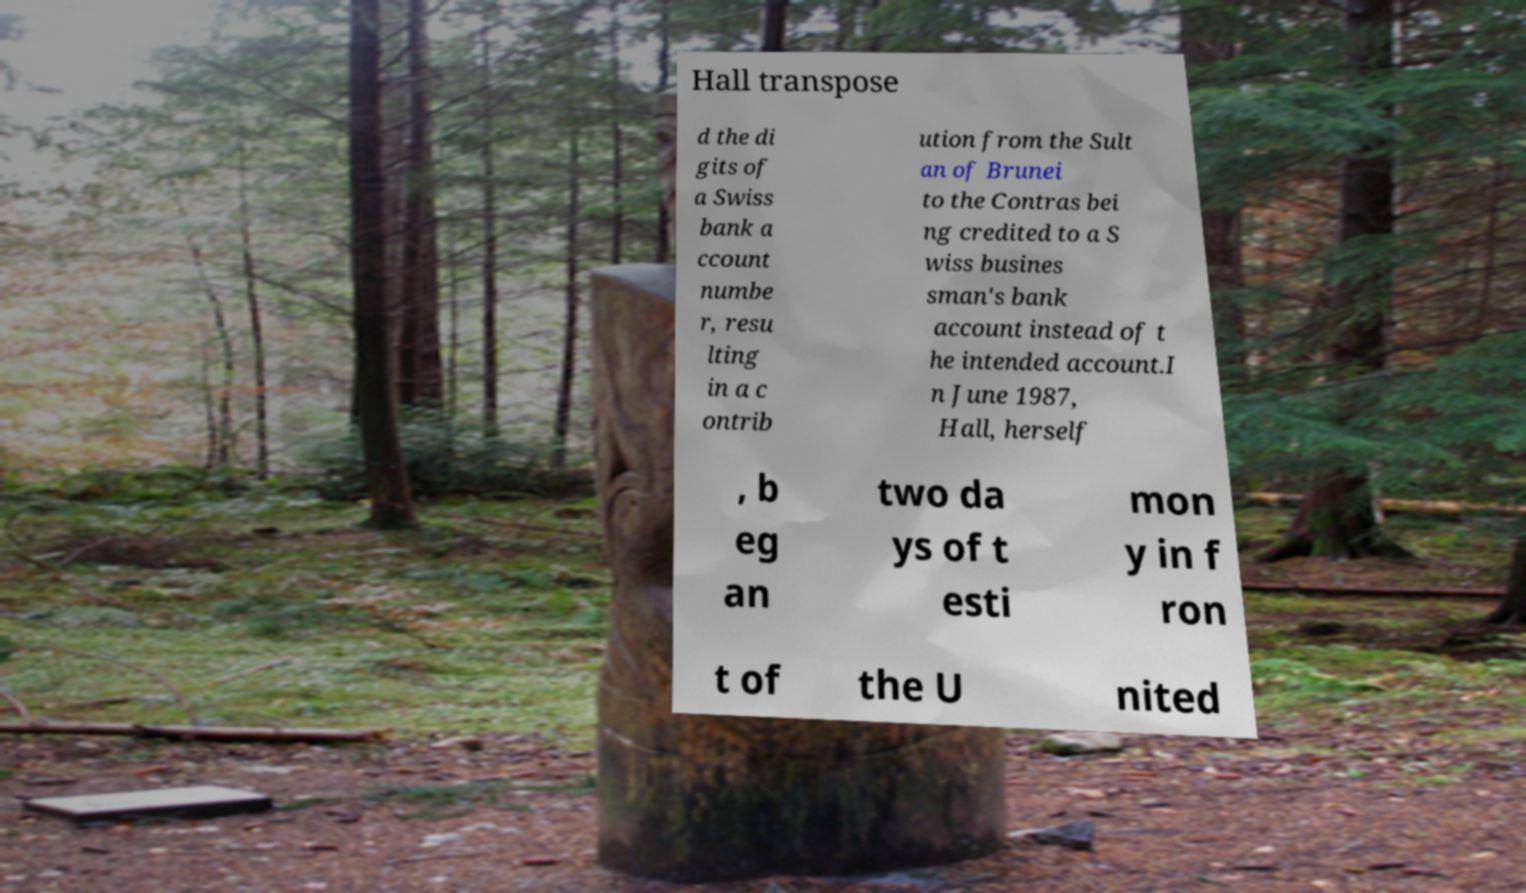What messages or text are displayed in this image? I need them in a readable, typed format. Hall transpose d the di gits of a Swiss bank a ccount numbe r, resu lting in a c ontrib ution from the Sult an of Brunei to the Contras bei ng credited to a S wiss busines sman's bank account instead of t he intended account.I n June 1987, Hall, herself , b eg an two da ys of t esti mon y in f ron t of the U nited 